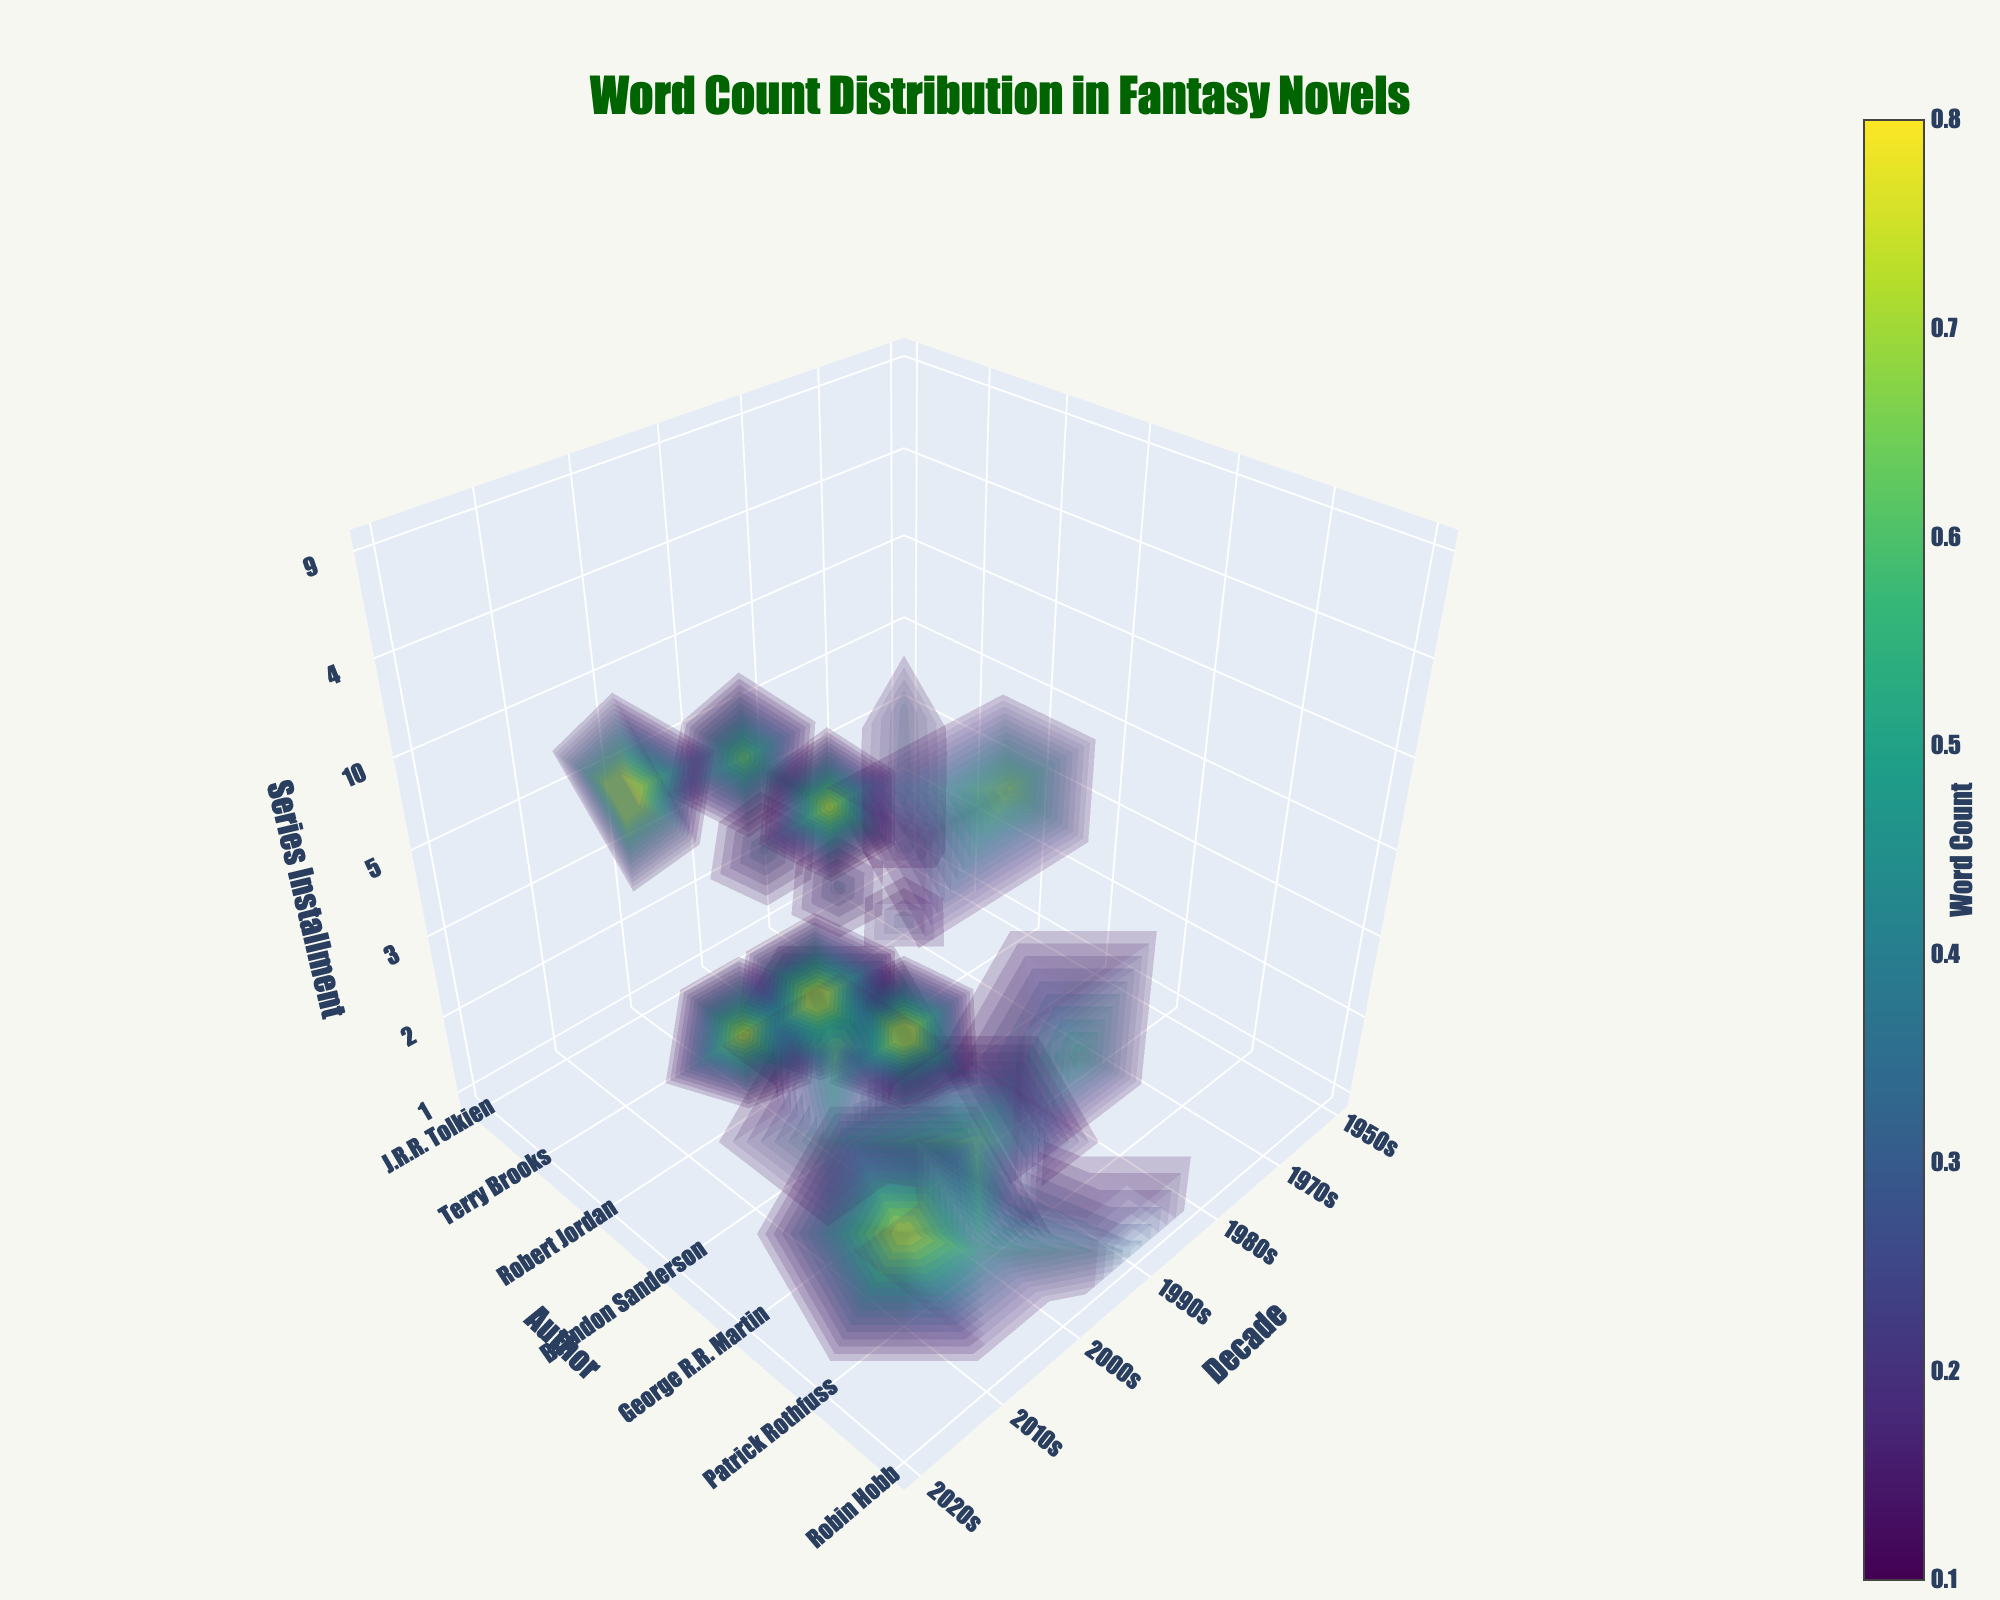What is the title of the plot? The title is usually displayed at the top of the plot. In this case, it centers on the main subject of visualization.
Answer: Word Count Distribution in Fantasy Novels How many authors' data are represented in this plot? By observing the axis labeled 'Author', we can count the number of unique tick marks which corresponds to the number of authors.
Answer: 7 Which author has the largest word count in a single series installment? By analyzing the color intensity in the 'Author' axis and locating the brightest/most intense color that represents the highest word count, we identify the author.
Answer: Brandon Sanderson Over which decades were J.R.R. Tolkien's novels published? By finding J.R.R. Tolkien on the 'Author' axis and observing the corresponding tick marks on the 'Decade' axis, we can determine the decades.
Answer: 1950s Which series installment number tends to have higher word counts: first installments or later installments? Compare the color intensities on the 'Series Installment' axis for the first installments and the later ones to see which is generally more intense, indicating higher word counts.
Answer: Later installments How does the word count of Robert Jordan's first installment compare with his tenth installment? Locate Robert Jordan on the 'Author' axis, then compare the color intensities for his first installment and tenth installment on the 'Series Installment' axis.
Answer: The tenth installment has a higher word count What is the average publication decade for George R.R. Martin's novels shown in this plot? Identify the tick marks for George R.R. Martin's novels on the 'Decade' axis, then compute the average of these decades. Taking into account 1990s, 2000s, and 2010s, the average is (1990 + 2000 + 2010) / 3.
Answer: 2000s Which author has the least intense overall color representation on the plot? Survey the plot for the author with the overall darkest color intensity, which represents the lowest word counts.
Answer: Robin Hobb What is the range of years covered by the novels in this plot? Observe the tick marks on the 'Decade' axis to determine the earliest and latest decades represented.
Answer: 1950s to 2020s Which author has the highest variation in word count across different series installments? By comparing the ranges and variabilities of color intensities for each author across multiple series installments, determine the author with the greatest disparity.
Answer: George R.R. Martin 